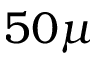Convert formula to latex. <formula><loc_0><loc_0><loc_500><loc_500>5 0 \mu</formula> 